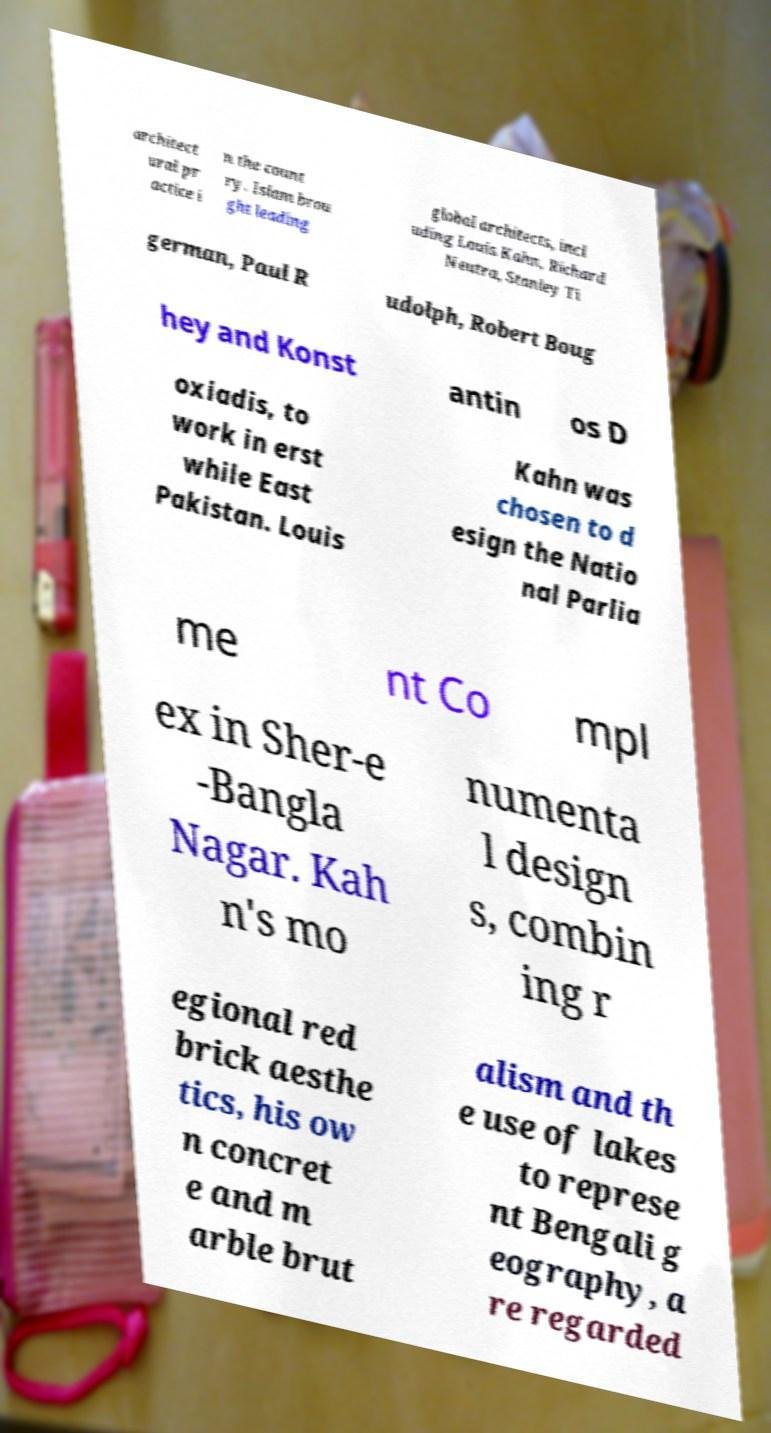I need the written content from this picture converted into text. Can you do that? architect ural pr actice i n the count ry. Islam brou ght leading global architects, incl uding Louis Kahn, Richard Neutra, Stanley Ti german, Paul R udolph, Robert Boug hey and Konst antin os D oxiadis, to work in erst while East Pakistan. Louis Kahn was chosen to d esign the Natio nal Parlia me nt Co mpl ex in Sher-e -Bangla Nagar. Kah n's mo numenta l design s, combin ing r egional red brick aesthe tics, his ow n concret e and m arble brut alism and th e use of lakes to represe nt Bengali g eography, a re regarded 